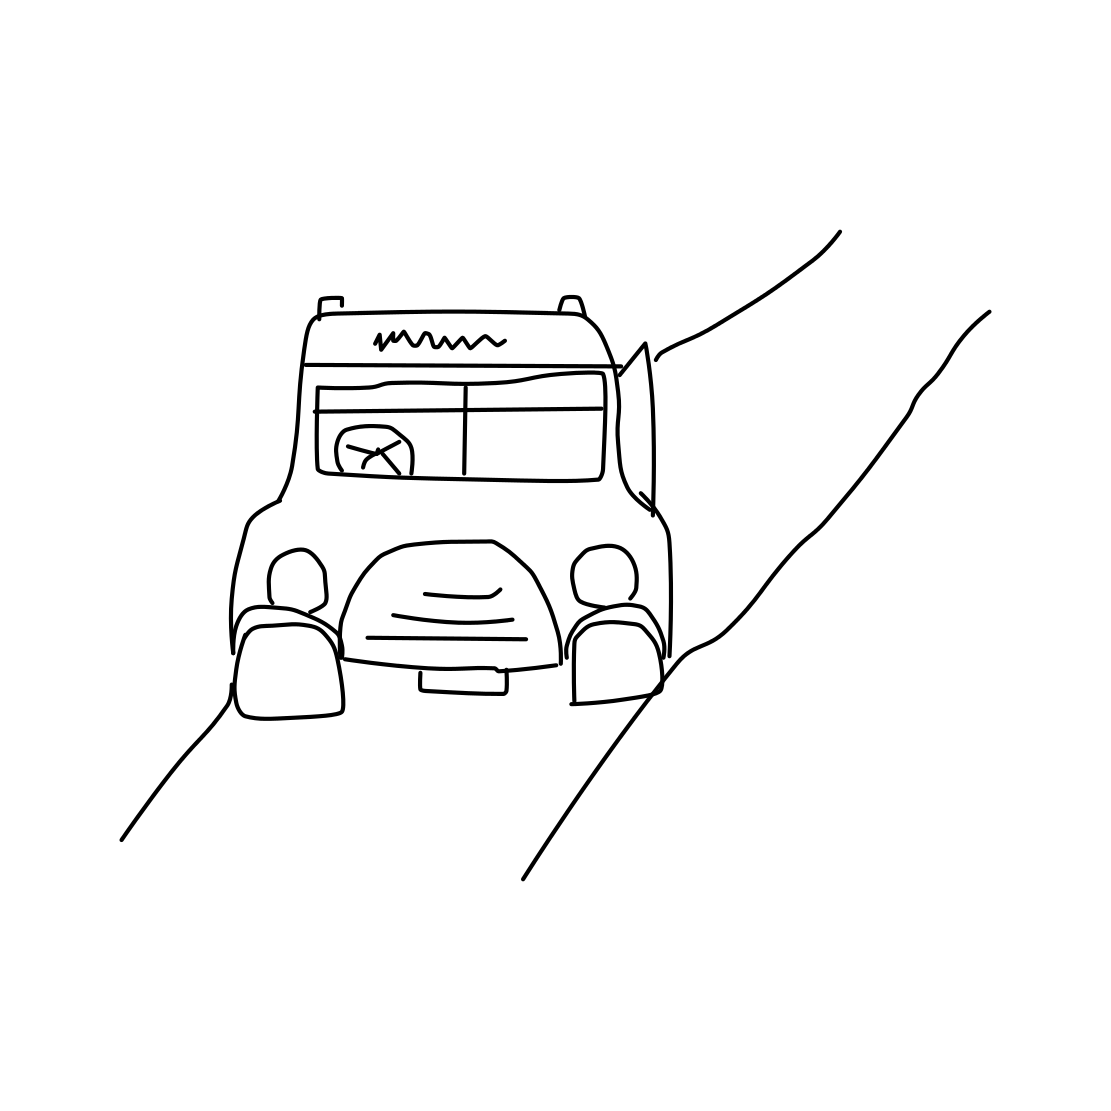What might this type of truck be typically used for? A truck of this style, with its sizeable cargo bed, would likely be used for transporting goods such as agricultural produce or general supplies. Its simple, sturdy design suggests it could handle everyday tasks rather well. 